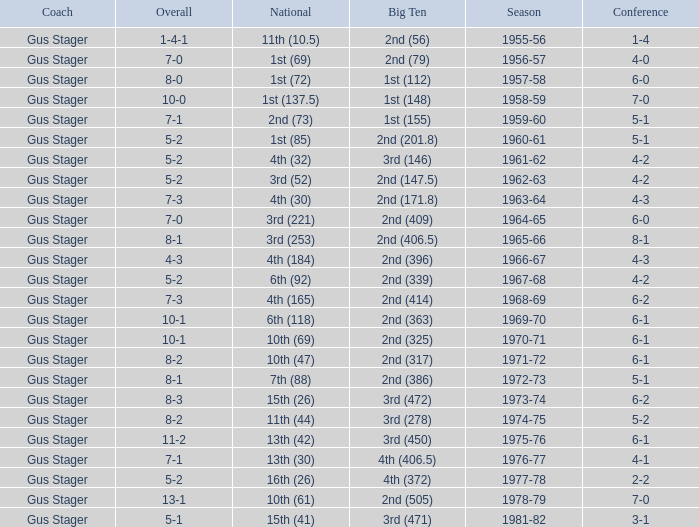What is the Coach with a Big Ten that is 2nd (79)? Gus Stager. 